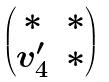Convert formula to latex. <formula><loc_0><loc_0><loc_500><loc_500>\begin{pmatrix} * & * \\ v _ { 4 } ^ { \prime } & * \end{pmatrix}</formula> 